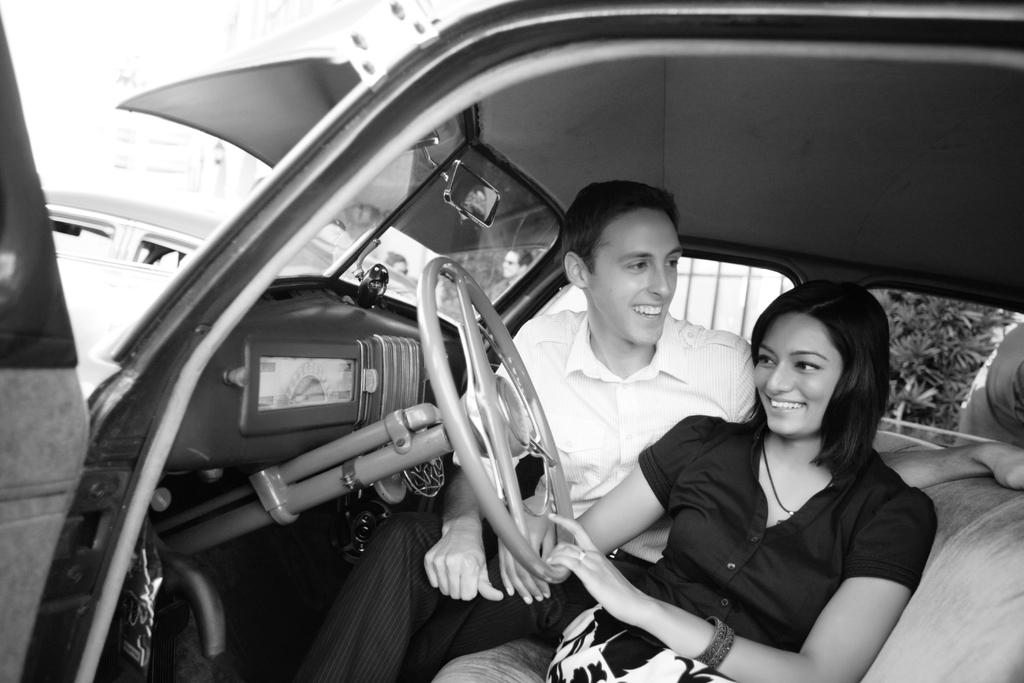What is the main subject of the image? The main subject of the image is a car. Who is inside the car? There are two persons sitting in the car. What is the facial expression of the persons in the car? The persons are smiling. What can be seen in the background of the image? There is a vehicle, a gate, a plant, and the sky visible in the background of the image. What type of nose can be seen on the car in the image? Cars do not have noses, as they are inanimate objects. The question is not applicable to the image. 